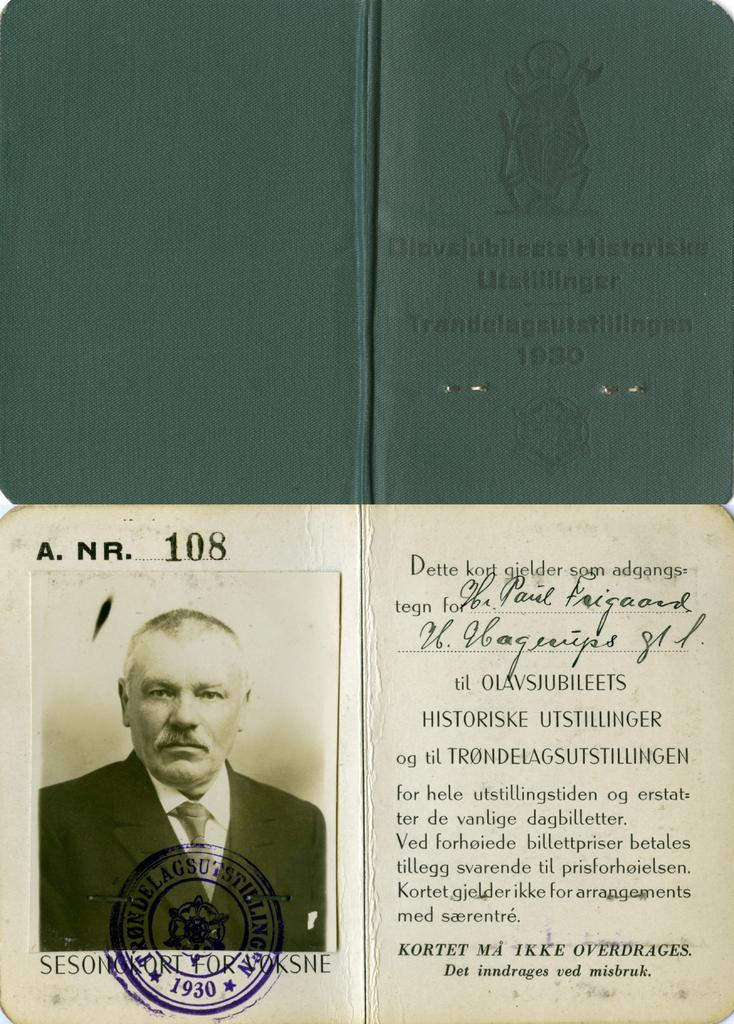<image>
Relay a brief, clear account of the picture shown. A green book from 1930 is open and shows a photo a man. 